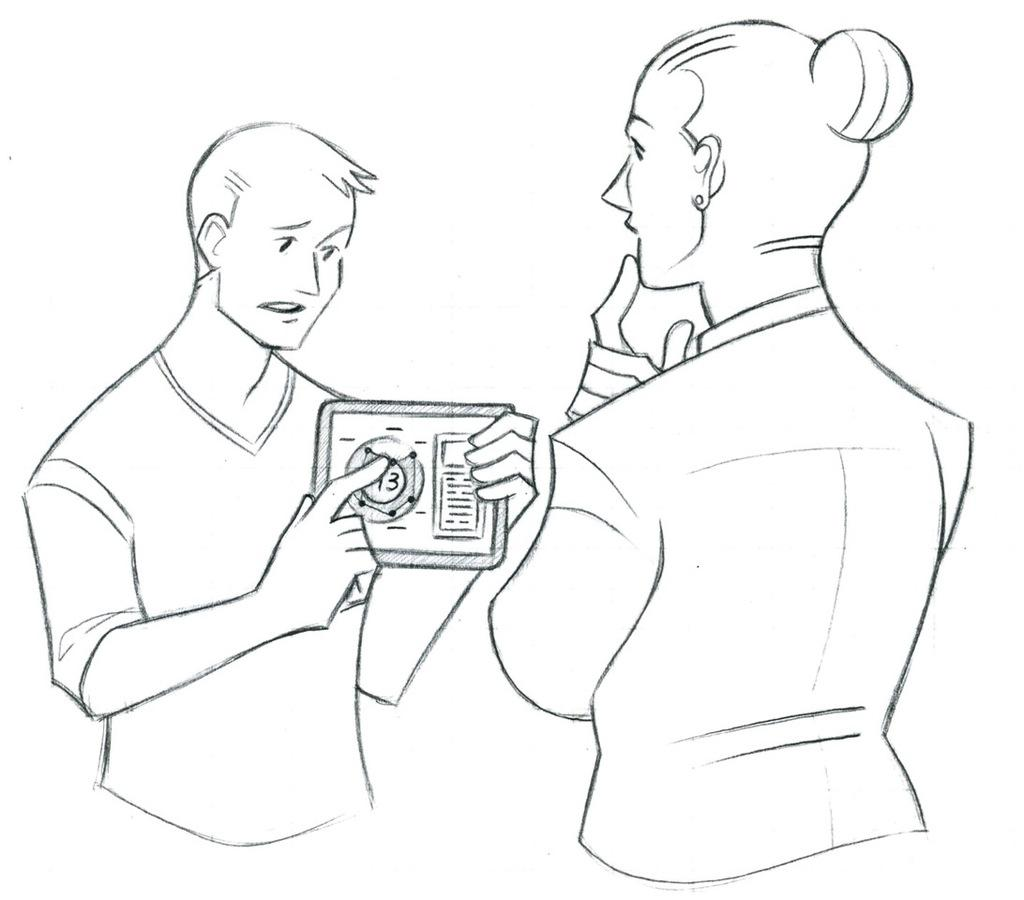What type of artwork is depicted in the image? The image is a drawing. What figures are present in the drawing? There is a man and a woman in the drawing. What is the man holding in his hand? The man is holding something in his hand, but the specific object is not mentioned in the facts. What type of mailbox is present in the drawing? There is no mailbox present in the drawing; it only features a man and a woman. How does the society depicted in the drawing function? The facts provided do not give any information about the society in the drawing, so it is impossible to answer this question. 